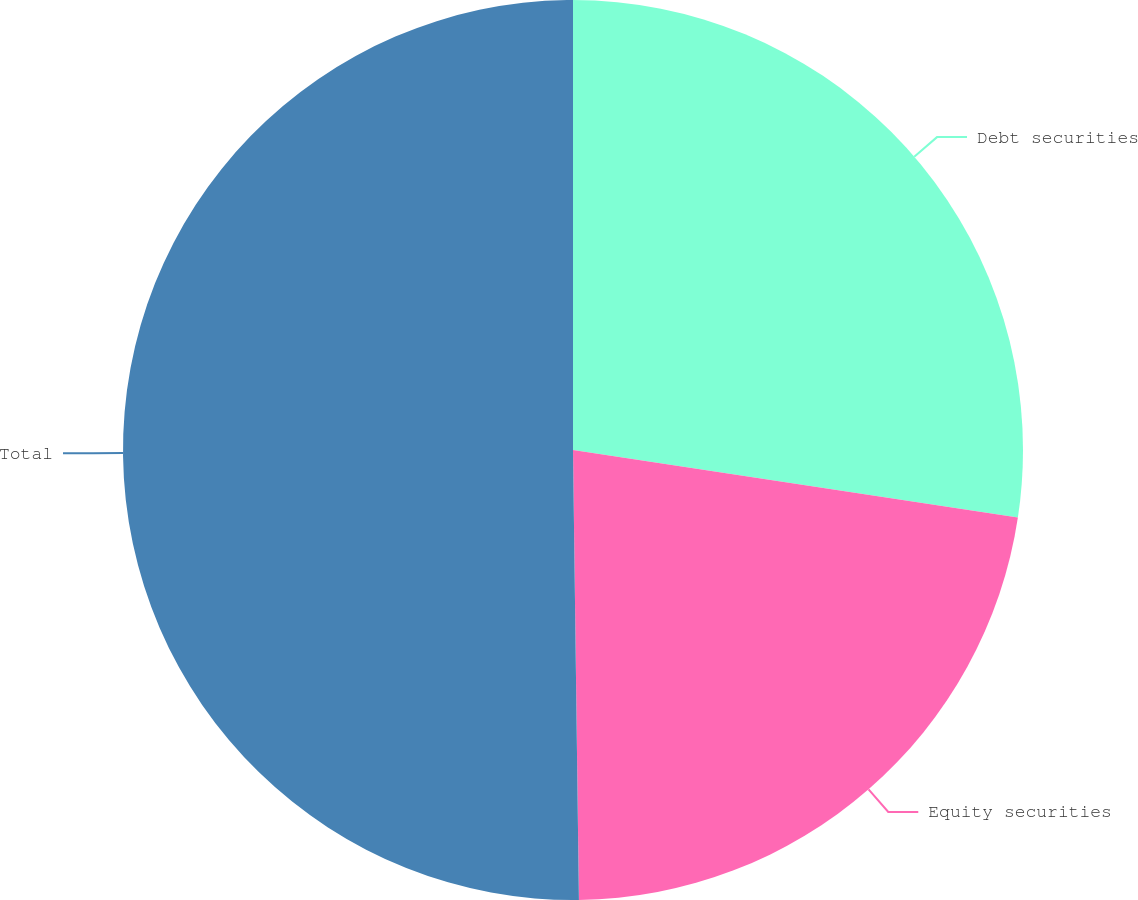Convert chart to OTSL. <chart><loc_0><loc_0><loc_500><loc_500><pie_chart><fcel>Debt securities<fcel>Equity securities<fcel>Total<nl><fcel>27.4%<fcel>22.39%<fcel>50.21%<nl></chart> 